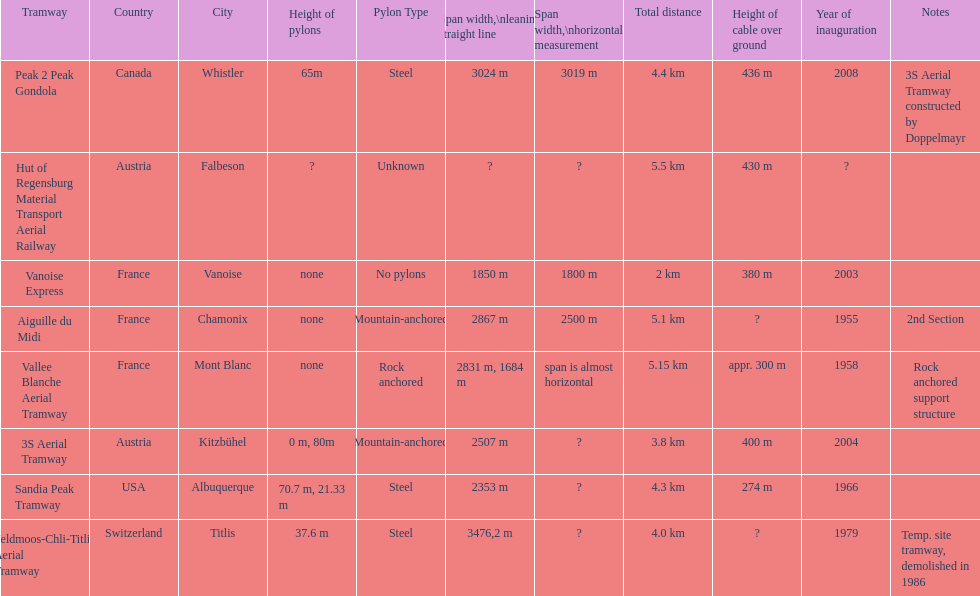How much greater is the height of cable over ground measurement for the peak 2 peak gondola when compared with that of the vanoise express? 56 m. 